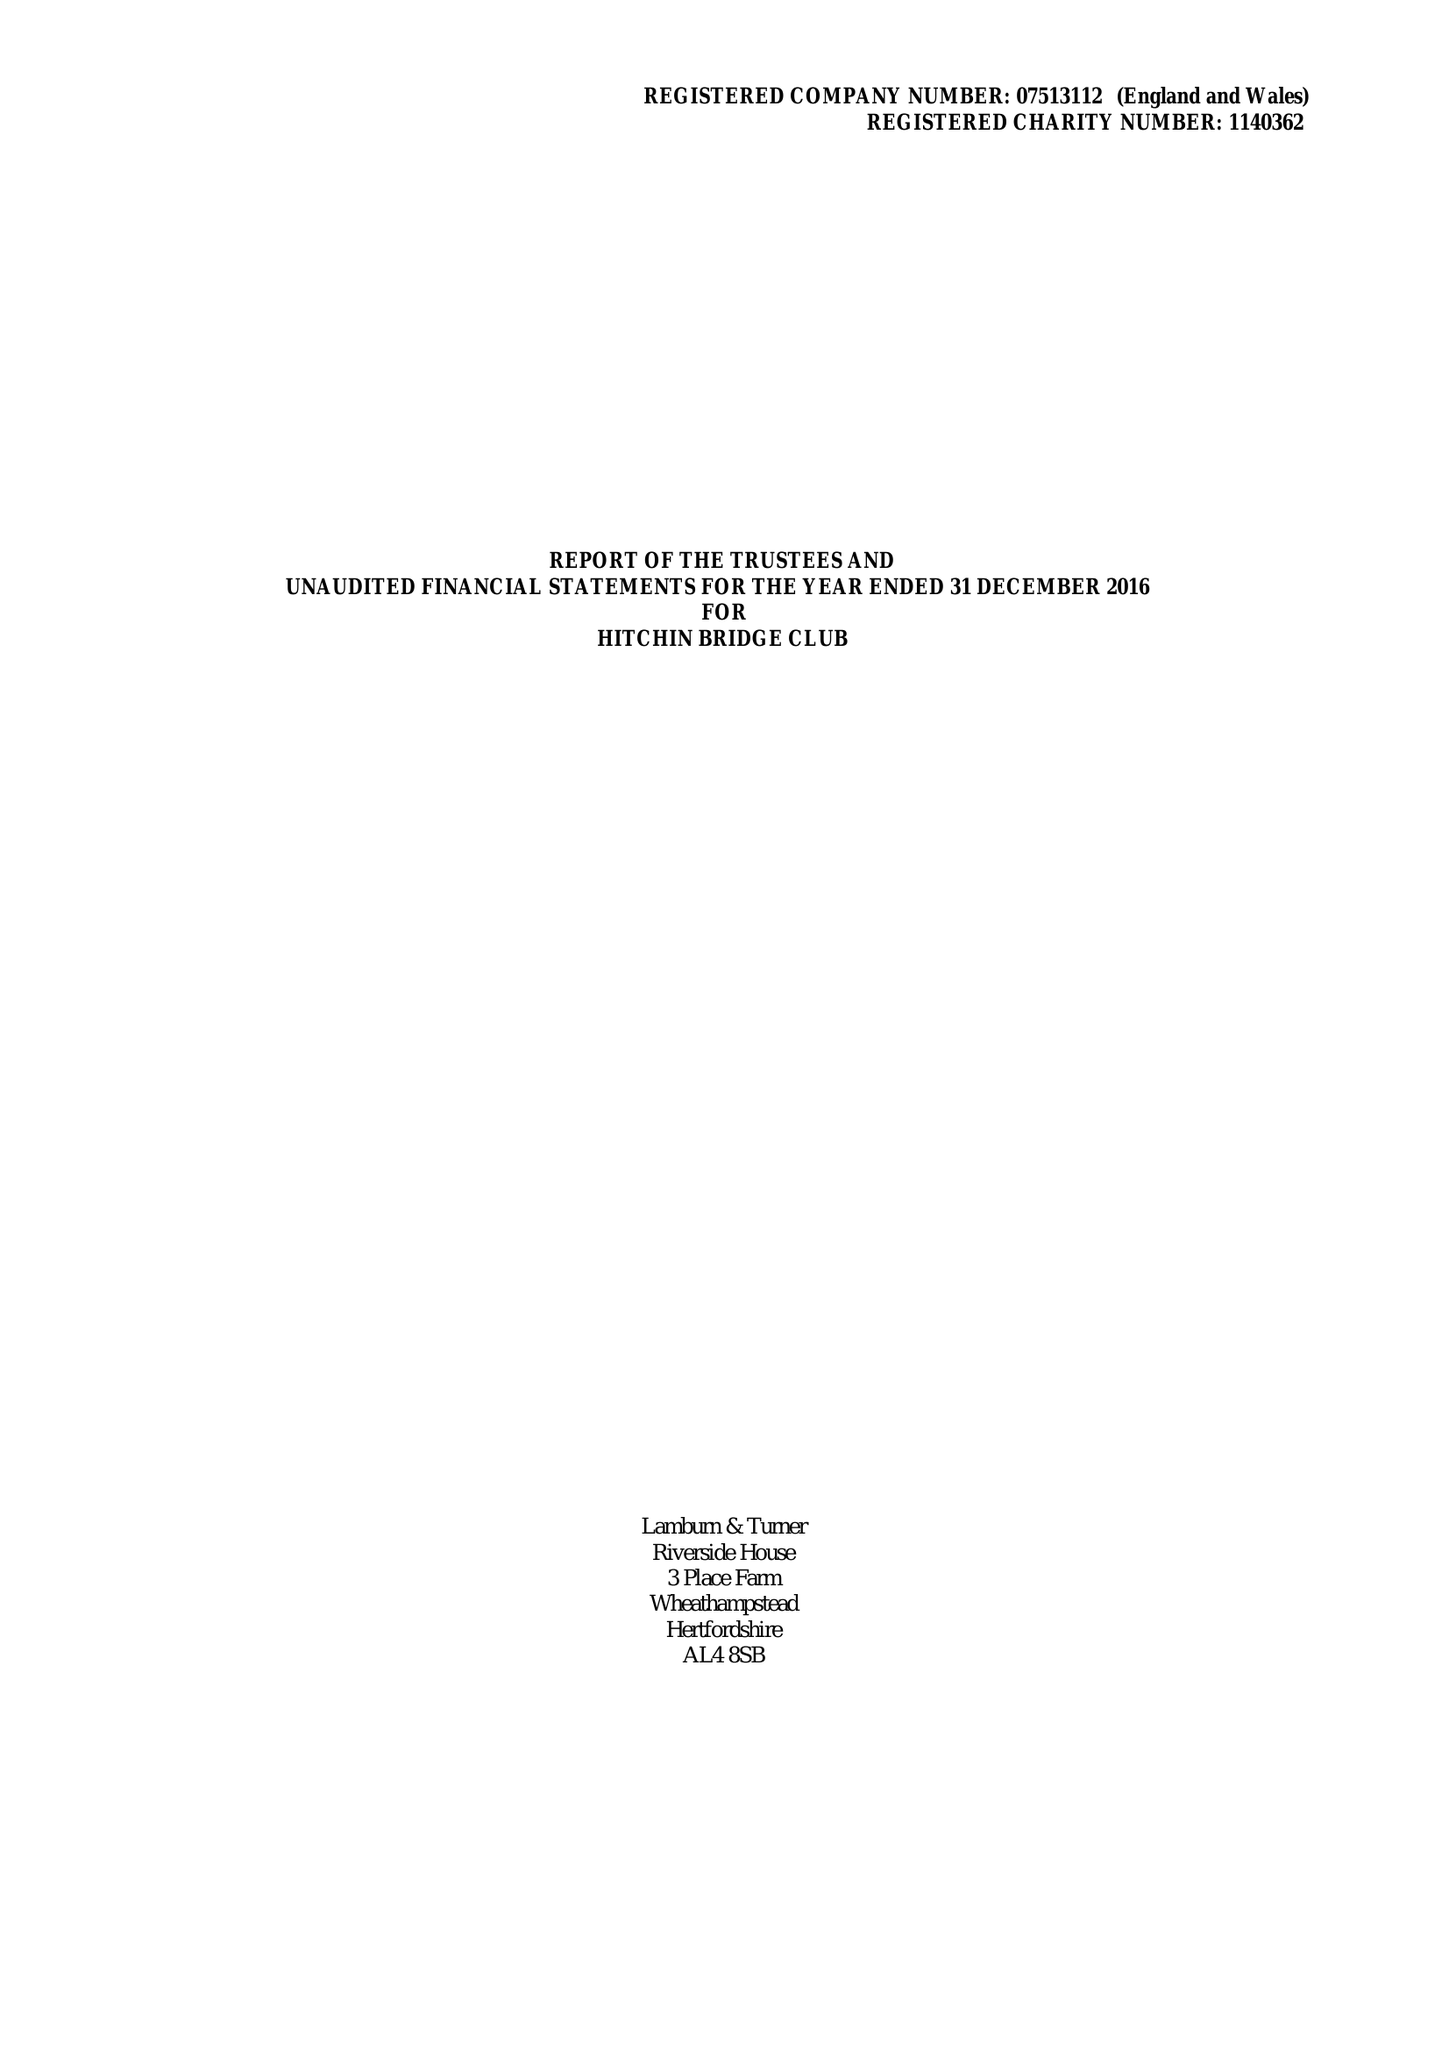What is the value for the address__postcode?
Answer the question using a single word or phrase. SG5 2HZ 